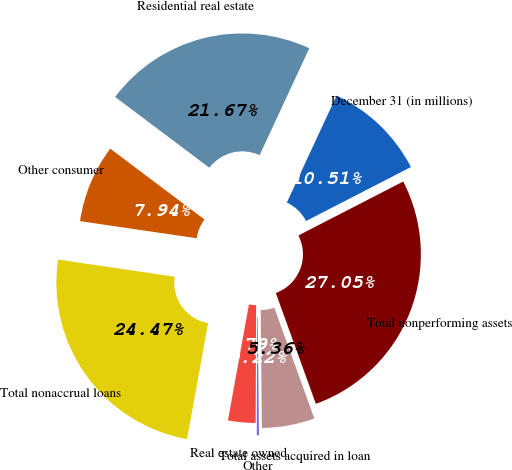Convert chart. <chart><loc_0><loc_0><loc_500><loc_500><pie_chart><fcel>December 31 (in millions)<fcel>Residential real estate<fcel>Other consumer<fcel>Total nonaccrual loans<fcel>Real estate owned<fcel>Other<fcel>Total assets acquired in loan<fcel>Total nonperforming assets<nl><fcel>10.51%<fcel>21.67%<fcel>7.94%<fcel>24.47%<fcel>2.79%<fcel>0.22%<fcel>5.36%<fcel>27.05%<nl></chart> 